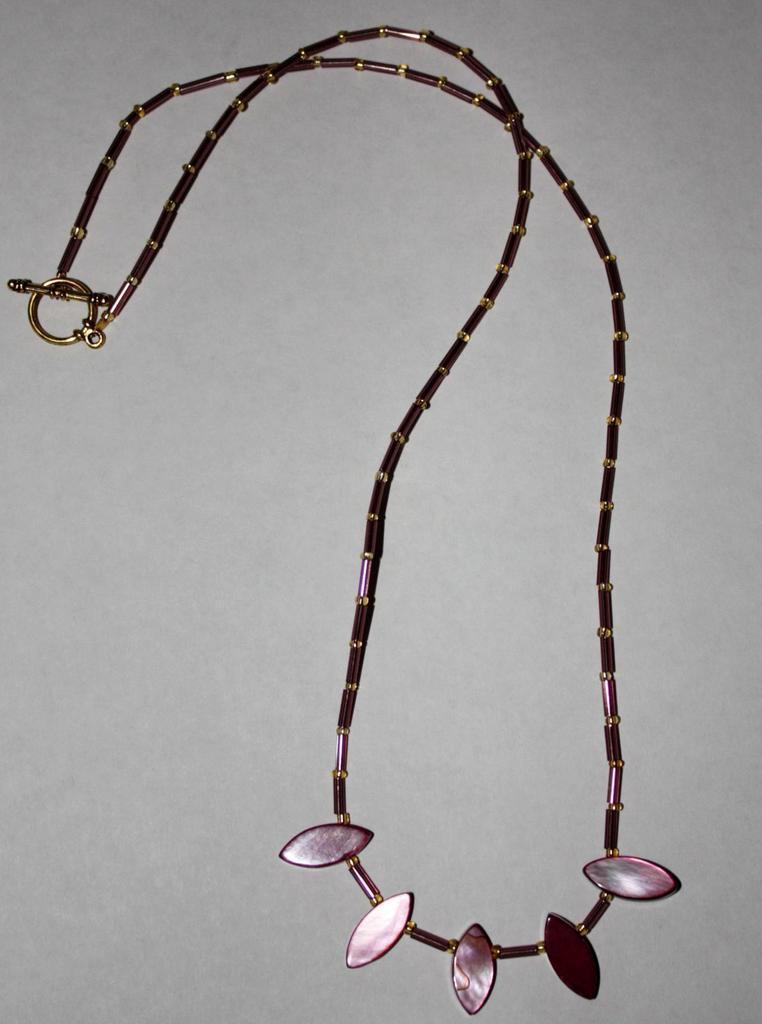In one or two sentences, can you explain what this image depicts? In this image we can see a neck chain with design on a surface. 